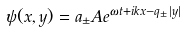Convert formula to latex. <formula><loc_0><loc_0><loc_500><loc_500>\psi ( x , y ) = a _ { \pm } A e ^ { \omega t + i k x - q _ { \pm } | y | }</formula> 